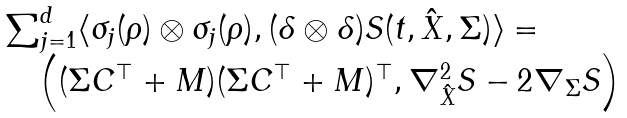Convert formula to latex. <formula><loc_0><loc_0><loc_500><loc_500>\begin{array} { l } \sum _ { j = 1 } ^ { d } \langle \sigma _ { j } ( \rho ) \otimes \sigma _ { j } ( \rho ) , ( \delta \otimes \delta ) S ( t , \hat { X } , \Sigma ) \rangle = \quad \\ \quad \left ( ( \Sigma C ^ { \top } + M ) ( \Sigma C ^ { \top } + M ) ^ { \top } , \nabla ^ { 2 } _ { \hat { X } } S - 2 \nabla _ { \Sigma } S \right ) \end{array}</formula> 